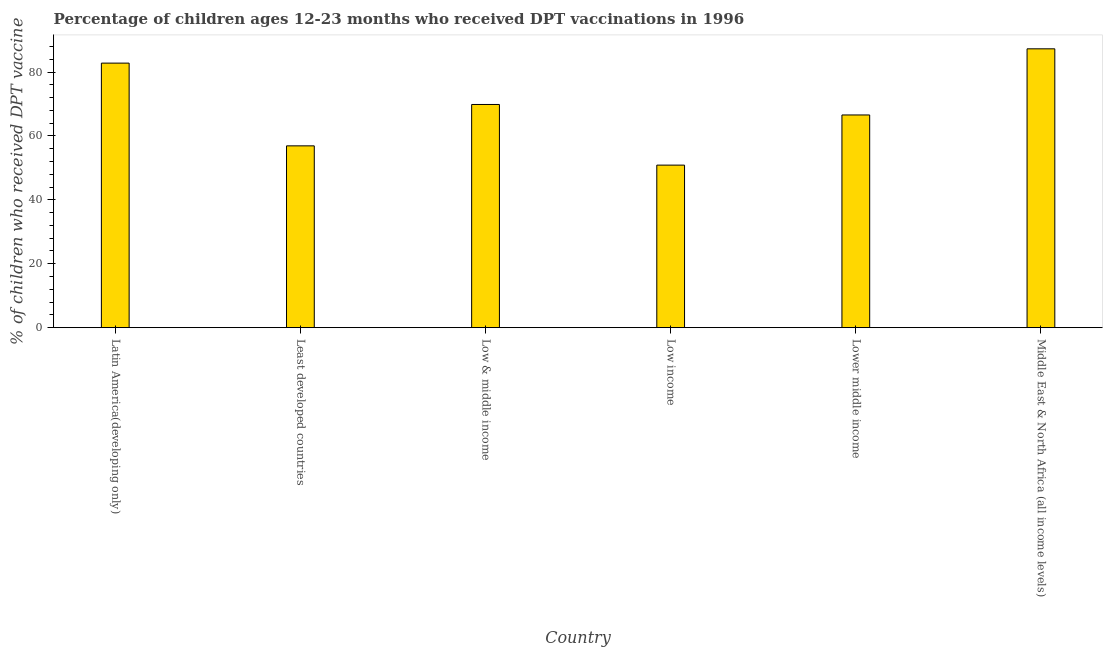Does the graph contain any zero values?
Ensure brevity in your answer.  No. What is the title of the graph?
Provide a short and direct response. Percentage of children ages 12-23 months who received DPT vaccinations in 1996. What is the label or title of the X-axis?
Provide a succinct answer. Country. What is the label or title of the Y-axis?
Your response must be concise. % of children who received DPT vaccine. What is the percentage of children who received dpt vaccine in Low & middle income?
Give a very brief answer. 69.84. Across all countries, what is the maximum percentage of children who received dpt vaccine?
Offer a terse response. 87.26. Across all countries, what is the minimum percentage of children who received dpt vaccine?
Provide a succinct answer. 50.86. In which country was the percentage of children who received dpt vaccine maximum?
Offer a very short reply. Middle East & North Africa (all income levels). What is the sum of the percentage of children who received dpt vaccine?
Keep it short and to the point. 414.19. What is the difference between the percentage of children who received dpt vaccine in Least developed countries and Low & middle income?
Provide a short and direct response. -12.95. What is the average percentage of children who received dpt vaccine per country?
Offer a very short reply. 69.03. What is the median percentage of children who received dpt vaccine?
Give a very brief answer. 68.2. What is the ratio of the percentage of children who received dpt vaccine in Low & middle income to that in Low income?
Provide a succinct answer. 1.37. Is the percentage of children who received dpt vaccine in Low & middle income less than that in Lower middle income?
Offer a terse response. No. Is the difference between the percentage of children who received dpt vaccine in Latin America(developing only) and Lower middle income greater than the difference between any two countries?
Your answer should be compact. No. What is the difference between the highest and the second highest percentage of children who received dpt vaccine?
Your answer should be very brief. 4.48. Is the sum of the percentage of children who received dpt vaccine in Least developed countries and Lower middle income greater than the maximum percentage of children who received dpt vaccine across all countries?
Your answer should be compact. Yes. What is the difference between the highest and the lowest percentage of children who received dpt vaccine?
Provide a short and direct response. 36.39. Are all the bars in the graph horizontal?
Your response must be concise. No. How many countries are there in the graph?
Make the answer very short. 6. What is the difference between two consecutive major ticks on the Y-axis?
Offer a terse response. 20. Are the values on the major ticks of Y-axis written in scientific E-notation?
Give a very brief answer. No. What is the % of children who received DPT vaccine in Latin America(developing only)?
Make the answer very short. 82.78. What is the % of children who received DPT vaccine in Least developed countries?
Provide a succinct answer. 56.89. What is the % of children who received DPT vaccine in Low & middle income?
Provide a short and direct response. 69.84. What is the % of children who received DPT vaccine in Low income?
Your answer should be very brief. 50.86. What is the % of children who received DPT vaccine in Lower middle income?
Offer a very short reply. 66.56. What is the % of children who received DPT vaccine of Middle East & North Africa (all income levels)?
Provide a short and direct response. 87.26. What is the difference between the % of children who received DPT vaccine in Latin America(developing only) and Least developed countries?
Provide a short and direct response. 25.89. What is the difference between the % of children who received DPT vaccine in Latin America(developing only) and Low & middle income?
Provide a short and direct response. 12.94. What is the difference between the % of children who received DPT vaccine in Latin America(developing only) and Low income?
Your answer should be very brief. 31.92. What is the difference between the % of children who received DPT vaccine in Latin America(developing only) and Lower middle income?
Provide a succinct answer. 16.22. What is the difference between the % of children who received DPT vaccine in Latin America(developing only) and Middle East & North Africa (all income levels)?
Give a very brief answer. -4.48. What is the difference between the % of children who received DPT vaccine in Least developed countries and Low & middle income?
Your answer should be very brief. -12.95. What is the difference between the % of children who received DPT vaccine in Least developed countries and Low income?
Ensure brevity in your answer.  6.03. What is the difference between the % of children who received DPT vaccine in Least developed countries and Lower middle income?
Offer a terse response. -9.67. What is the difference between the % of children who received DPT vaccine in Least developed countries and Middle East & North Africa (all income levels)?
Your answer should be very brief. -30.37. What is the difference between the % of children who received DPT vaccine in Low & middle income and Low income?
Give a very brief answer. 18.98. What is the difference between the % of children who received DPT vaccine in Low & middle income and Lower middle income?
Your answer should be compact. 3.29. What is the difference between the % of children who received DPT vaccine in Low & middle income and Middle East & North Africa (all income levels)?
Keep it short and to the point. -17.41. What is the difference between the % of children who received DPT vaccine in Low income and Lower middle income?
Make the answer very short. -15.69. What is the difference between the % of children who received DPT vaccine in Low income and Middle East & North Africa (all income levels)?
Make the answer very short. -36.39. What is the difference between the % of children who received DPT vaccine in Lower middle income and Middle East & North Africa (all income levels)?
Provide a short and direct response. -20.7. What is the ratio of the % of children who received DPT vaccine in Latin America(developing only) to that in Least developed countries?
Provide a short and direct response. 1.46. What is the ratio of the % of children who received DPT vaccine in Latin America(developing only) to that in Low & middle income?
Your response must be concise. 1.19. What is the ratio of the % of children who received DPT vaccine in Latin America(developing only) to that in Low income?
Your answer should be very brief. 1.63. What is the ratio of the % of children who received DPT vaccine in Latin America(developing only) to that in Lower middle income?
Keep it short and to the point. 1.24. What is the ratio of the % of children who received DPT vaccine in Latin America(developing only) to that in Middle East & North Africa (all income levels)?
Provide a succinct answer. 0.95. What is the ratio of the % of children who received DPT vaccine in Least developed countries to that in Low & middle income?
Make the answer very short. 0.81. What is the ratio of the % of children who received DPT vaccine in Least developed countries to that in Low income?
Your answer should be compact. 1.12. What is the ratio of the % of children who received DPT vaccine in Least developed countries to that in Lower middle income?
Provide a short and direct response. 0.85. What is the ratio of the % of children who received DPT vaccine in Least developed countries to that in Middle East & North Africa (all income levels)?
Ensure brevity in your answer.  0.65. What is the ratio of the % of children who received DPT vaccine in Low & middle income to that in Low income?
Ensure brevity in your answer.  1.37. What is the ratio of the % of children who received DPT vaccine in Low & middle income to that in Lower middle income?
Make the answer very short. 1.05. What is the ratio of the % of children who received DPT vaccine in Low income to that in Lower middle income?
Provide a succinct answer. 0.76. What is the ratio of the % of children who received DPT vaccine in Low income to that in Middle East & North Africa (all income levels)?
Keep it short and to the point. 0.58. What is the ratio of the % of children who received DPT vaccine in Lower middle income to that in Middle East & North Africa (all income levels)?
Your answer should be compact. 0.76. 